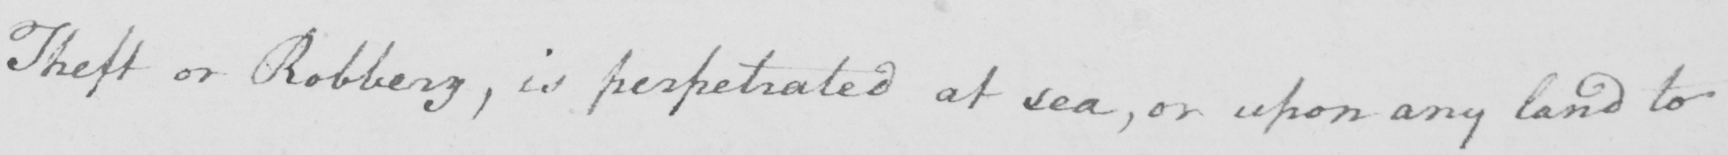Can you tell me what this handwritten text says? Theft or robbery  , is perpetrated at sea  , or upon any land to 